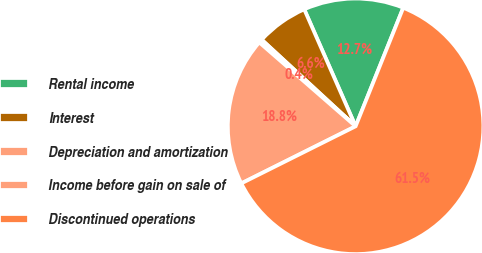Convert chart. <chart><loc_0><loc_0><loc_500><loc_500><pie_chart><fcel>Rental income<fcel>Interest<fcel>Depreciation and amortization<fcel>Income before gain on sale of<fcel>Discontinued operations<nl><fcel>12.67%<fcel>6.56%<fcel>0.45%<fcel>18.78%<fcel>61.55%<nl></chart> 